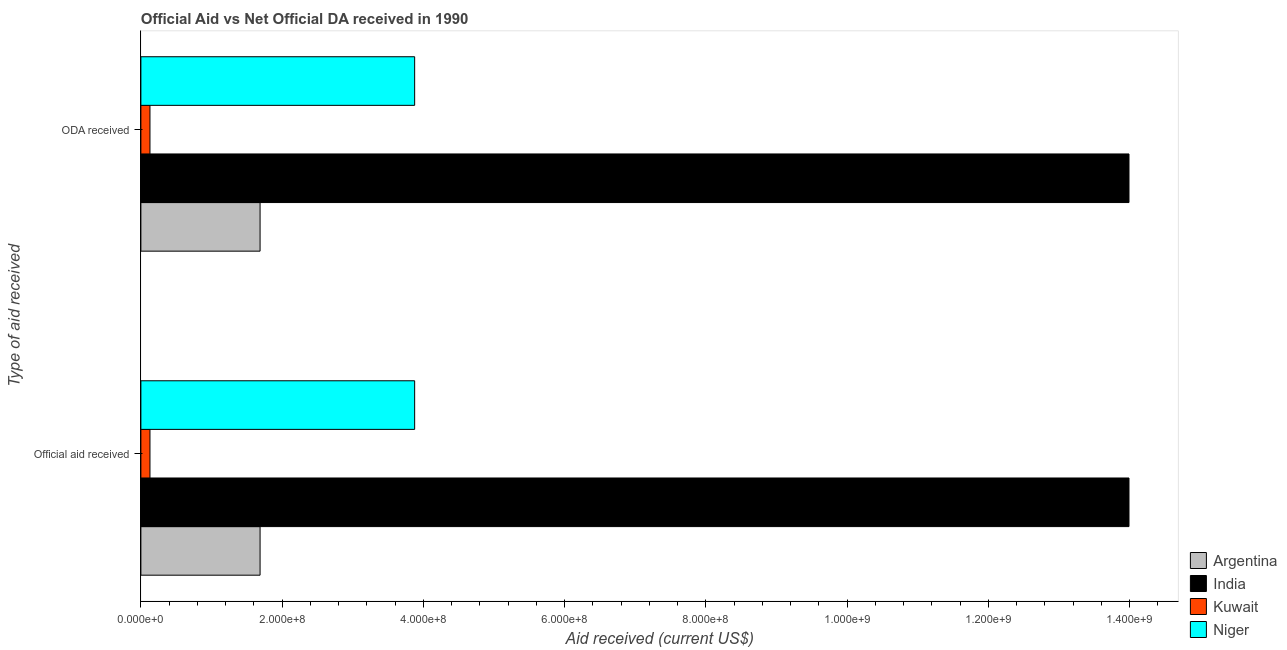How many different coloured bars are there?
Give a very brief answer. 4. How many groups of bars are there?
Your answer should be compact. 2. Are the number of bars per tick equal to the number of legend labels?
Provide a succinct answer. Yes. Are the number of bars on each tick of the Y-axis equal?
Give a very brief answer. Yes. What is the label of the 2nd group of bars from the top?
Make the answer very short. Official aid received. What is the oda received in Argentina?
Offer a terse response. 1.69e+08. Across all countries, what is the maximum official aid received?
Make the answer very short. 1.40e+09. Across all countries, what is the minimum oda received?
Make the answer very short. 1.29e+07. In which country was the official aid received maximum?
Your response must be concise. India. In which country was the official aid received minimum?
Give a very brief answer. Kuwait. What is the total oda received in the graph?
Keep it short and to the point. 1.97e+09. What is the difference between the oda received in Niger and that in Kuwait?
Your response must be concise. 3.75e+08. What is the difference between the official aid received in India and the oda received in Kuwait?
Offer a very short reply. 1.39e+09. What is the average official aid received per country?
Offer a terse response. 4.92e+08. In how many countries, is the official aid received greater than 560000000 US$?
Provide a succinct answer. 1. What is the ratio of the oda received in Niger to that in Argentina?
Give a very brief answer. 2.3. Is the oda received in Kuwait less than that in Argentina?
Provide a short and direct response. Yes. What does the 2nd bar from the top in ODA received represents?
Your answer should be very brief. Kuwait. What does the 4th bar from the bottom in Official aid received represents?
Offer a terse response. Niger. Are all the bars in the graph horizontal?
Your answer should be very brief. Yes. How many countries are there in the graph?
Your answer should be compact. 4. What is the difference between two consecutive major ticks on the X-axis?
Keep it short and to the point. 2.00e+08. Does the graph contain grids?
Make the answer very short. No. Where does the legend appear in the graph?
Give a very brief answer. Bottom right. What is the title of the graph?
Your answer should be compact. Official Aid vs Net Official DA received in 1990 . What is the label or title of the X-axis?
Give a very brief answer. Aid received (current US$). What is the label or title of the Y-axis?
Your answer should be very brief. Type of aid received. What is the Aid received (current US$) of Argentina in Official aid received?
Offer a terse response. 1.69e+08. What is the Aid received (current US$) in India in Official aid received?
Offer a terse response. 1.40e+09. What is the Aid received (current US$) in Kuwait in Official aid received?
Your answer should be compact. 1.29e+07. What is the Aid received (current US$) in Niger in Official aid received?
Your response must be concise. 3.88e+08. What is the Aid received (current US$) in Argentina in ODA received?
Offer a terse response. 1.69e+08. What is the Aid received (current US$) in India in ODA received?
Make the answer very short. 1.40e+09. What is the Aid received (current US$) of Kuwait in ODA received?
Keep it short and to the point. 1.29e+07. What is the Aid received (current US$) in Niger in ODA received?
Ensure brevity in your answer.  3.88e+08. Across all Type of aid received, what is the maximum Aid received (current US$) of Argentina?
Your answer should be compact. 1.69e+08. Across all Type of aid received, what is the maximum Aid received (current US$) in India?
Ensure brevity in your answer.  1.40e+09. Across all Type of aid received, what is the maximum Aid received (current US$) in Kuwait?
Keep it short and to the point. 1.29e+07. Across all Type of aid received, what is the maximum Aid received (current US$) of Niger?
Make the answer very short. 3.88e+08. Across all Type of aid received, what is the minimum Aid received (current US$) of Argentina?
Your answer should be compact. 1.69e+08. Across all Type of aid received, what is the minimum Aid received (current US$) of India?
Your answer should be very brief. 1.40e+09. Across all Type of aid received, what is the minimum Aid received (current US$) in Kuwait?
Provide a succinct answer. 1.29e+07. Across all Type of aid received, what is the minimum Aid received (current US$) of Niger?
Offer a terse response. 3.88e+08. What is the total Aid received (current US$) in Argentina in the graph?
Ensure brevity in your answer.  3.37e+08. What is the total Aid received (current US$) of India in the graph?
Keep it short and to the point. 2.80e+09. What is the total Aid received (current US$) in Kuwait in the graph?
Keep it short and to the point. 2.57e+07. What is the total Aid received (current US$) in Niger in the graph?
Your answer should be very brief. 7.75e+08. What is the difference between the Aid received (current US$) of India in Official aid received and that in ODA received?
Ensure brevity in your answer.  0. What is the difference between the Aid received (current US$) in Kuwait in Official aid received and that in ODA received?
Your answer should be very brief. 0. What is the difference between the Aid received (current US$) in Niger in Official aid received and that in ODA received?
Give a very brief answer. 0. What is the difference between the Aid received (current US$) of Argentina in Official aid received and the Aid received (current US$) of India in ODA received?
Provide a short and direct response. -1.23e+09. What is the difference between the Aid received (current US$) in Argentina in Official aid received and the Aid received (current US$) in Kuwait in ODA received?
Offer a very short reply. 1.56e+08. What is the difference between the Aid received (current US$) in Argentina in Official aid received and the Aid received (current US$) in Niger in ODA received?
Your response must be concise. -2.19e+08. What is the difference between the Aid received (current US$) of India in Official aid received and the Aid received (current US$) of Kuwait in ODA received?
Offer a very short reply. 1.39e+09. What is the difference between the Aid received (current US$) in India in Official aid received and the Aid received (current US$) in Niger in ODA received?
Give a very brief answer. 1.01e+09. What is the difference between the Aid received (current US$) in Kuwait in Official aid received and the Aid received (current US$) in Niger in ODA received?
Offer a very short reply. -3.75e+08. What is the average Aid received (current US$) of Argentina per Type of aid received?
Your answer should be very brief. 1.69e+08. What is the average Aid received (current US$) in India per Type of aid received?
Give a very brief answer. 1.40e+09. What is the average Aid received (current US$) in Kuwait per Type of aid received?
Offer a terse response. 1.29e+07. What is the average Aid received (current US$) of Niger per Type of aid received?
Keep it short and to the point. 3.88e+08. What is the difference between the Aid received (current US$) in Argentina and Aid received (current US$) in India in Official aid received?
Provide a short and direct response. -1.23e+09. What is the difference between the Aid received (current US$) of Argentina and Aid received (current US$) of Kuwait in Official aid received?
Offer a very short reply. 1.56e+08. What is the difference between the Aid received (current US$) in Argentina and Aid received (current US$) in Niger in Official aid received?
Keep it short and to the point. -2.19e+08. What is the difference between the Aid received (current US$) in India and Aid received (current US$) in Kuwait in Official aid received?
Provide a succinct answer. 1.39e+09. What is the difference between the Aid received (current US$) of India and Aid received (current US$) of Niger in Official aid received?
Provide a short and direct response. 1.01e+09. What is the difference between the Aid received (current US$) of Kuwait and Aid received (current US$) of Niger in Official aid received?
Keep it short and to the point. -3.75e+08. What is the difference between the Aid received (current US$) in Argentina and Aid received (current US$) in India in ODA received?
Keep it short and to the point. -1.23e+09. What is the difference between the Aid received (current US$) in Argentina and Aid received (current US$) in Kuwait in ODA received?
Offer a very short reply. 1.56e+08. What is the difference between the Aid received (current US$) in Argentina and Aid received (current US$) in Niger in ODA received?
Keep it short and to the point. -2.19e+08. What is the difference between the Aid received (current US$) of India and Aid received (current US$) of Kuwait in ODA received?
Your answer should be compact. 1.39e+09. What is the difference between the Aid received (current US$) in India and Aid received (current US$) in Niger in ODA received?
Your response must be concise. 1.01e+09. What is the difference between the Aid received (current US$) in Kuwait and Aid received (current US$) in Niger in ODA received?
Offer a very short reply. -3.75e+08. What is the ratio of the Aid received (current US$) in Argentina in Official aid received to that in ODA received?
Offer a very short reply. 1. What is the ratio of the Aid received (current US$) in India in Official aid received to that in ODA received?
Provide a succinct answer. 1. What is the difference between the highest and the second highest Aid received (current US$) of India?
Your response must be concise. 0. What is the difference between the highest and the lowest Aid received (current US$) in India?
Make the answer very short. 0. What is the difference between the highest and the lowest Aid received (current US$) of Kuwait?
Keep it short and to the point. 0. What is the difference between the highest and the lowest Aid received (current US$) in Niger?
Your answer should be very brief. 0. 